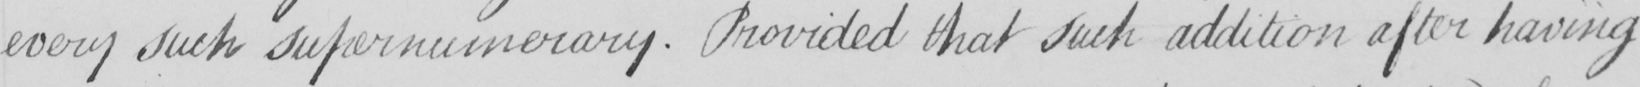What text is written in this handwritten line? every such supernumerary . Provided that such addition after having 